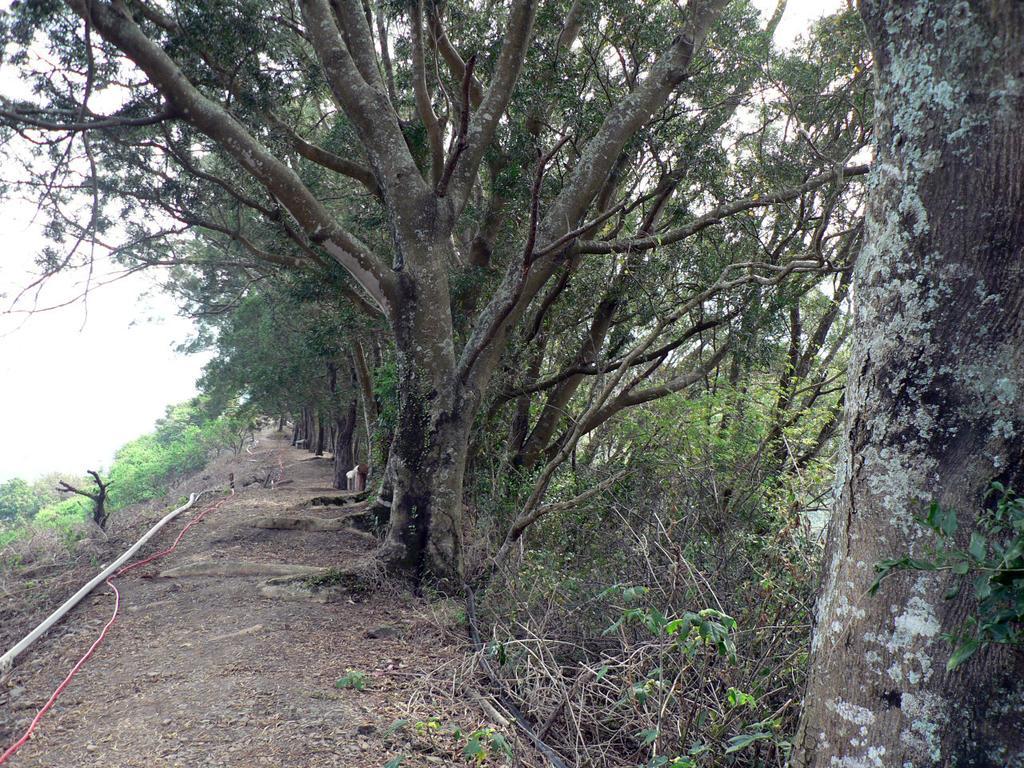How would you summarize this image in a sentence or two? In this image we can see many trees and the sky in the background. 